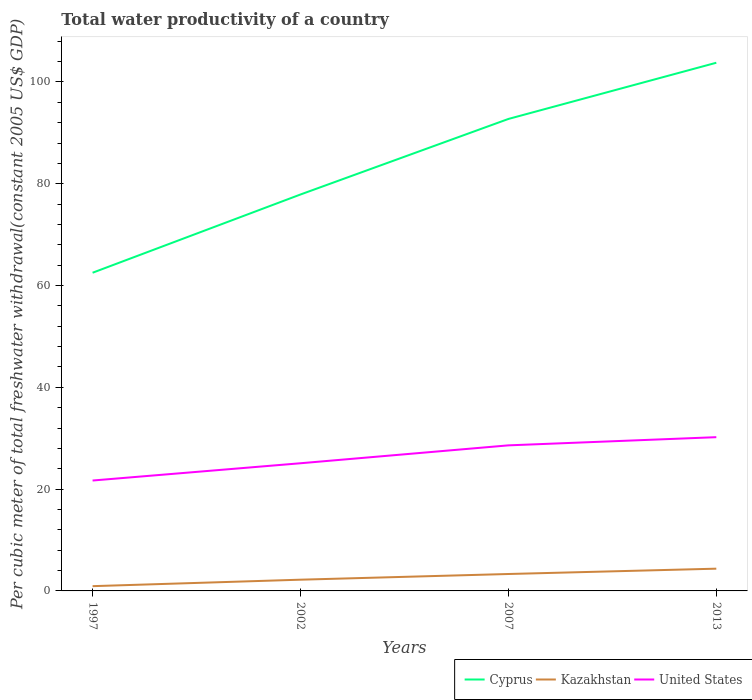Does the line corresponding to Cyprus intersect with the line corresponding to United States?
Your answer should be very brief. No. Is the number of lines equal to the number of legend labels?
Ensure brevity in your answer.  Yes. Across all years, what is the maximum total water productivity in Kazakhstan?
Provide a succinct answer. 0.94. What is the total total water productivity in Cyprus in the graph?
Your answer should be very brief. -14.84. What is the difference between the highest and the second highest total water productivity in Kazakhstan?
Your response must be concise. 3.44. Is the total water productivity in Cyprus strictly greater than the total water productivity in United States over the years?
Offer a very short reply. No. How many lines are there?
Make the answer very short. 3. How many years are there in the graph?
Your answer should be very brief. 4. What is the difference between two consecutive major ticks on the Y-axis?
Keep it short and to the point. 20. Are the values on the major ticks of Y-axis written in scientific E-notation?
Keep it short and to the point. No. Does the graph contain grids?
Keep it short and to the point. No. How many legend labels are there?
Ensure brevity in your answer.  3. How are the legend labels stacked?
Your answer should be very brief. Horizontal. What is the title of the graph?
Keep it short and to the point. Total water productivity of a country. What is the label or title of the Y-axis?
Ensure brevity in your answer.  Per cubic meter of total freshwater withdrawal(constant 2005 US$ GDP). What is the Per cubic meter of total freshwater withdrawal(constant 2005 US$ GDP) of Cyprus in 1997?
Your answer should be very brief. 62.52. What is the Per cubic meter of total freshwater withdrawal(constant 2005 US$ GDP) of Kazakhstan in 1997?
Your answer should be very brief. 0.94. What is the Per cubic meter of total freshwater withdrawal(constant 2005 US$ GDP) in United States in 1997?
Keep it short and to the point. 21.69. What is the Per cubic meter of total freshwater withdrawal(constant 2005 US$ GDP) of Cyprus in 2002?
Offer a terse response. 77.89. What is the Per cubic meter of total freshwater withdrawal(constant 2005 US$ GDP) of Kazakhstan in 2002?
Offer a very short reply. 2.21. What is the Per cubic meter of total freshwater withdrawal(constant 2005 US$ GDP) in United States in 2002?
Your answer should be very brief. 25.08. What is the Per cubic meter of total freshwater withdrawal(constant 2005 US$ GDP) in Cyprus in 2007?
Ensure brevity in your answer.  92.73. What is the Per cubic meter of total freshwater withdrawal(constant 2005 US$ GDP) in Kazakhstan in 2007?
Your answer should be compact. 3.32. What is the Per cubic meter of total freshwater withdrawal(constant 2005 US$ GDP) of United States in 2007?
Offer a terse response. 28.6. What is the Per cubic meter of total freshwater withdrawal(constant 2005 US$ GDP) of Cyprus in 2013?
Your answer should be compact. 103.77. What is the Per cubic meter of total freshwater withdrawal(constant 2005 US$ GDP) in Kazakhstan in 2013?
Make the answer very short. 4.37. What is the Per cubic meter of total freshwater withdrawal(constant 2005 US$ GDP) in United States in 2013?
Your answer should be compact. 30.21. Across all years, what is the maximum Per cubic meter of total freshwater withdrawal(constant 2005 US$ GDP) of Cyprus?
Your answer should be compact. 103.77. Across all years, what is the maximum Per cubic meter of total freshwater withdrawal(constant 2005 US$ GDP) in Kazakhstan?
Your answer should be compact. 4.37. Across all years, what is the maximum Per cubic meter of total freshwater withdrawal(constant 2005 US$ GDP) in United States?
Keep it short and to the point. 30.21. Across all years, what is the minimum Per cubic meter of total freshwater withdrawal(constant 2005 US$ GDP) of Cyprus?
Your answer should be very brief. 62.52. Across all years, what is the minimum Per cubic meter of total freshwater withdrawal(constant 2005 US$ GDP) in Kazakhstan?
Keep it short and to the point. 0.94. Across all years, what is the minimum Per cubic meter of total freshwater withdrawal(constant 2005 US$ GDP) in United States?
Your response must be concise. 21.69. What is the total Per cubic meter of total freshwater withdrawal(constant 2005 US$ GDP) in Cyprus in the graph?
Provide a succinct answer. 336.9. What is the total Per cubic meter of total freshwater withdrawal(constant 2005 US$ GDP) in Kazakhstan in the graph?
Ensure brevity in your answer.  10.84. What is the total Per cubic meter of total freshwater withdrawal(constant 2005 US$ GDP) of United States in the graph?
Provide a succinct answer. 105.58. What is the difference between the Per cubic meter of total freshwater withdrawal(constant 2005 US$ GDP) in Cyprus in 1997 and that in 2002?
Provide a succinct answer. -15.37. What is the difference between the Per cubic meter of total freshwater withdrawal(constant 2005 US$ GDP) of Kazakhstan in 1997 and that in 2002?
Your answer should be very brief. -1.27. What is the difference between the Per cubic meter of total freshwater withdrawal(constant 2005 US$ GDP) in United States in 1997 and that in 2002?
Your response must be concise. -3.39. What is the difference between the Per cubic meter of total freshwater withdrawal(constant 2005 US$ GDP) of Cyprus in 1997 and that in 2007?
Offer a terse response. -30.21. What is the difference between the Per cubic meter of total freshwater withdrawal(constant 2005 US$ GDP) of Kazakhstan in 1997 and that in 2007?
Give a very brief answer. -2.39. What is the difference between the Per cubic meter of total freshwater withdrawal(constant 2005 US$ GDP) in United States in 1997 and that in 2007?
Your response must be concise. -6.91. What is the difference between the Per cubic meter of total freshwater withdrawal(constant 2005 US$ GDP) in Cyprus in 1997 and that in 2013?
Provide a short and direct response. -41.26. What is the difference between the Per cubic meter of total freshwater withdrawal(constant 2005 US$ GDP) of Kazakhstan in 1997 and that in 2013?
Keep it short and to the point. -3.44. What is the difference between the Per cubic meter of total freshwater withdrawal(constant 2005 US$ GDP) in United States in 1997 and that in 2013?
Provide a succinct answer. -8.52. What is the difference between the Per cubic meter of total freshwater withdrawal(constant 2005 US$ GDP) of Cyprus in 2002 and that in 2007?
Your answer should be compact. -14.84. What is the difference between the Per cubic meter of total freshwater withdrawal(constant 2005 US$ GDP) in Kazakhstan in 2002 and that in 2007?
Keep it short and to the point. -1.12. What is the difference between the Per cubic meter of total freshwater withdrawal(constant 2005 US$ GDP) of United States in 2002 and that in 2007?
Offer a terse response. -3.52. What is the difference between the Per cubic meter of total freshwater withdrawal(constant 2005 US$ GDP) in Cyprus in 2002 and that in 2013?
Give a very brief answer. -25.88. What is the difference between the Per cubic meter of total freshwater withdrawal(constant 2005 US$ GDP) in Kazakhstan in 2002 and that in 2013?
Your response must be concise. -2.17. What is the difference between the Per cubic meter of total freshwater withdrawal(constant 2005 US$ GDP) in United States in 2002 and that in 2013?
Provide a short and direct response. -5.12. What is the difference between the Per cubic meter of total freshwater withdrawal(constant 2005 US$ GDP) of Cyprus in 2007 and that in 2013?
Provide a succinct answer. -11.04. What is the difference between the Per cubic meter of total freshwater withdrawal(constant 2005 US$ GDP) in Kazakhstan in 2007 and that in 2013?
Your answer should be compact. -1.05. What is the difference between the Per cubic meter of total freshwater withdrawal(constant 2005 US$ GDP) in United States in 2007 and that in 2013?
Your answer should be compact. -1.61. What is the difference between the Per cubic meter of total freshwater withdrawal(constant 2005 US$ GDP) of Cyprus in 1997 and the Per cubic meter of total freshwater withdrawal(constant 2005 US$ GDP) of Kazakhstan in 2002?
Your response must be concise. 60.31. What is the difference between the Per cubic meter of total freshwater withdrawal(constant 2005 US$ GDP) of Cyprus in 1997 and the Per cubic meter of total freshwater withdrawal(constant 2005 US$ GDP) of United States in 2002?
Keep it short and to the point. 37.43. What is the difference between the Per cubic meter of total freshwater withdrawal(constant 2005 US$ GDP) of Kazakhstan in 1997 and the Per cubic meter of total freshwater withdrawal(constant 2005 US$ GDP) of United States in 2002?
Your response must be concise. -24.15. What is the difference between the Per cubic meter of total freshwater withdrawal(constant 2005 US$ GDP) in Cyprus in 1997 and the Per cubic meter of total freshwater withdrawal(constant 2005 US$ GDP) in Kazakhstan in 2007?
Your answer should be very brief. 59.19. What is the difference between the Per cubic meter of total freshwater withdrawal(constant 2005 US$ GDP) of Cyprus in 1997 and the Per cubic meter of total freshwater withdrawal(constant 2005 US$ GDP) of United States in 2007?
Give a very brief answer. 33.92. What is the difference between the Per cubic meter of total freshwater withdrawal(constant 2005 US$ GDP) of Kazakhstan in 1997 and the Per cubic meter of total freshwater withdrawal(constant 2005 US$ GDP) of United States in 2007?
Your response must be concise. -27.66. What is the difference between the Per cubic meter of total freshwater withdrawal(constant 2005 US$ GDP) in Cyprus in 1997 and the Per cubic meter of total freshwater withdrawal(constant 2005 US$ GDP) in Kazakhstan in 2013?
Your answer should be very brief. 58.14. What is the difference between the Per cubic meter of total freshwater withdrawal(constant 2005 US$ GDP) of Cyprus in 1997 and the Per cubic meter of total freshwater withdrawal(constant 2005 US$ GDP) of United States in 2013?
Provide a short and direct response. 32.31. What is the difference between the Per cubic meter of total freshwater withdrawal(constant 2005 US$ GDP) of Kazakhstan in 1997 and the Per cubic meter of total freshwater withdrawal(constant 2005 US$ GDP) of United States in 2013?
Your answer should be compact. -29.27. What is the difference between the Per cubic meter of total freshwater withdrawal(constant 2005 US$ GDP) of Cyprus in 2002 and the Per cubic meter of total freshwater withdrawal(constant 2005 US$ GDP) of Kazakhstan in 2007?
Your response must be concise. 74.56. What is the difference between the Per cubic meter of total freshwater withdrawal(constant 2005 US$ GDP) in Cyprus in 2002 and the Per cubic meter of total freshwater withdrawal(constant 2005 US$ GDP) in United States in 2007?
Provide a short and direct response. 49.29. What is the difference between the Per cubic meter of total freshwater withdrawal(constant 2005 US$ GDP) in Kazakhstan in 2002 and the Per cubic meter of total freshwater withdrawal(constant 2005 US$ GDP) in United States in 2007?
Make the answer very short. -26.39. What is the difference between the Per cubic meter of total freshwater withdrawal(constant 2005 US$ GDP) of Cyprus in 2002 and the Per cubic meter of total freshwater withdrawal(constant 2005 US$ GDP) of Kazakhstan in 2013?
Make the answer very short. 73.52. What is the difference between the Per cubic meter of total freshwater withdrawal(constant 2005 US$ GDP) in Cyprus in 2002 and the Per cubic meter of total freshwater withdrawal(constant 2005 US$ GDP) in United States in 2013?
Make the answer very short. 47.68. What is the difference between the Per cubic meter of total freshwater withdrawal(constant 2005 US$ GDP) of Kazakhstan in 2002 and the Per cubic meter of total freshwater withdrawal(constant 2005 US$ GDP) of United States in 2013?
Your response must be concise. -28. What is the difference between the Per cubic meter of total freshwater withdrawal(constant 2005 US$ GDP) in Cyprus in 2007 and the Per cubic meter of total freshwater withdrawal(constant 2005 US$ GDP) in Kazakhstan in 2013?
Your response must be concise. 88.36. What is the difference between the Per cubic meter of total freshwater withdrawal(constant 2005 US$ GDP) of Cyprus in 2007 and the Per cubic meter of total freshwater withdrawal(constant 2005 US$ GDP) of United States in 2013?
Offer a terse response. 62.52. What is the difference between the Per cubic meter of total freshwater withdrawal(constant 2005 US$ GDP) in Kazakhstan in 2007 and the Per cubic meter of total freshwater withdrawal(constant 2005 US$ GDP) in United States in 2013?
Offer a terse response. -26.88. What is the average Per cubic meter of total freshwater withdrawal(constant 2005 US$ GDP) in Cyprus per year?
Your answer should be compact. 84.23. What is the average Per cubic meter of total freshwater withdrawal(constant 2005 US$ GDP) of Kazakhstan per year?
Your response must be concise. 2.71. What is the average Per cubic meter of total freshwater withdrawal(constant 2005 US$ GDP) in United States per year?
Ensure brevity in your answer.  26.4. In the year 1997, what is the difference between the Per cubic meter of total freshwater withdrawal(constant 2005 US$ GDP) in Cyprus and Per cubic meter of total freshwater withdrawal(constant 2005 US$ GDP) in Kazakhstan?
Ensure brevity in your answer.  61.58. In the year 1997, what is the difference between the Per cubic meter of total freshwater withdrawal(constant 2005 US$ GDP) of Cyprus and Per cubic meter of total freshwater withdrawal(constant 2005 US$ GDP) of United States?
Provide a succinct answer. 40.83. In the year 1997, what is the difference between the Per cubic meter of total freshwater withdrawal(constant 2005 US$ GDP) of Kazakhstan and Per cubic meter of total freshwater withdrawal(constant 2005 US$ GDP) of United States?
Give a very brief answer. -20.75. In the year 2002, what is the difference between the Per cubic meter of total freshwater withdrawal(constant 2005 US$ GDP) of Cyprus and Per cubic meter of total freshwater withdrawal(constant 2005 US$ GDP) of Kazakhstan?
Your answer should be compact. 75.68. In the year 2002, what is the difference between the Per cubic meter of total freshwater withdrawal(constant 2005 US$ GDP) of Cyprus and Per cubic meter of total freshwater withdrawal(constant 2005 US$ GDP) of United States?
Offer a very short reply. 52.8. In the year 2002, what is the difference between the Per cubic meter of total freshwater withdrawal(constant 2005 US$ GDP) in Kazakhstan and Per cubic meter of total freshwater withdrawal(constant 2005 US$ GDP) in United States?
Offer a very short reply. -22.88. In the year 2007, what is the difference between the Per cubic meter of total freshwater withdrawal(constant 2005 US$ GDP) of Cyprus and Per cubic meter of total freshwater withdrawal(constant 2005 US$ GDP) of Kazakhstan?
Offer a very short reply. 89.41. In the year 2007, what is the difference between the Per cubic meter of total freshwater withdrawal(constant 2005 US$ GDP) in Cyprus and Per cubic meter of total freshwater withdrawal(constant 2005 US$ GDP) in United States?
Make the answer very short. 64.13. In the year 2007, what is the difference between the Per cubic meter of total freshwater withdrawal(constant 2005 US$ GDP) of Kazakhstan and Per cubic meter of total freshwater withdrawal(constant 2005 US$ GDP) of United States?
Your response must be concise. -25.28. In the year 2013, what is the difference between the Per cubic meter of total freshwater withdrawal(constant 2005 US$ GDP) in Cyprus and Per cubic meter of total freshwater withdrawal(constant 2005 US$ GDP) in Kazakhstan?
Give a very brief answer. 99.4. In the year 2013, what is the difference between the Per cubic meter of total freshwater withdrawal(constant 2005 US$ GDP) in Cyprus and Per cubic meter of total freshwater withdrawal(constant 2005 US$ GDP) in United States?
Keep it short and to the point. 73.56. In the year 2013, what is the difference between the Per cubic meter of total freshwater withdrawal(constant 2005 US$ GDP) in Kazakhstan and Per cubic meter of total freshwater withdrawal(constant 2005 US$ GDP) in United States?
Offer a terse response. -25.84. What is the ratio of the Per cubic meter of total freshwater withdrawal(constant 2005 US$ GDP) in Cyprus in 1997 to that in 2002?
Ensure brevity in your answer.  0.8. What is the ratio of the Per cubic meter of total freshwater withdrawal(constant 2005 US$ GDP) of Kazakhstan in 1997 to that in 2002?
Make the answer very short. 0.42. What is the ratio of the Per cubic meter of total freshwater withdrawal(constant 2005 US$ GDP) of United States in 1997 to that in 2002?
Provide a short and direct response. 0.86. What is the ratio of the Per cubic meter of total freshwater withdrawal(constant 2005 US$ GDP) in Cyprus in 1997 to that in 2007?
Give a very brief answer. 0.67. What is the ratio of the Per cubic meter of total freshwater withdrawal(constant 2005 US$ GDP) in Kazakhstan in 1997 to that in 2007?
Keep it short and to the point. 0.28. What is the ratio of the Per cubic meter of total freshwater withdrawal(constant 2005 US$ GDP) in United States in 1997 to that in 2007?
Provide a succinct answer. 0.76. What is the ratio of the Per cubic meter of total freshwater withdrawal(constant 2005 US$ GDP) of Cyprus in 1997 to that in 2013?
Your answer should be very brief. 0.6. What is the ratio of the Per cubic meter of total freshwater withdrawal(constant 2005 US$ GDP) in Kazakhstan in 1997 to that in 2013?
Give a very brief answer. 0.21. What is the ratio of the Per cubic meter of total freshwater withdrawal(constant 2005 US$ GDP) in United States in 1997 to that in 2013?
Offer a terse response. 0.72. What is the ratio of the Per cubic meter of total freshwater withdrawal(constant 2005 US$ GDP) of Cyprus in 2002 to that in 2007?
Provide a short and direct response. 0.84. What is the ratio of the Per cubic meter of total freshwater withdrawal(constant 2005 US$ GDP) in Kazakhstan in 2002 to that in 2007?
Offer a very short reply. 0.66. What is the ratio of the Per cubic meter of total freshwater withdrawal(constant 2005 US$ GDP) in United States in 2002 to that in 2007?
Keep it short and to the point. 0.88. What is the ratio of the Per cubic meter of total freshwater withdrawal(constant 2005 US$ GDP) of Cyprus in 2002 to that in 2013?
Provide a short and direct response. 0.75. What is the ratio of the Per cubic meter of total freshwater withdrawal(constant 2005 US$ GDP) of Kazakhstan in 2002 to that in 2013?
Offer a very short reply. 0.5. What is the ratio of the Per cubic meter of total freshwater withdrawal(constant 2005 US$ GDP) in United States in 2002 to that in 2013?
Make the answer very short. 0.83. What is the ratio of the Per cubic meter of total freshwater withdrawal(constant 2005 US$ GDP) of Cyprus in 2007 to that in 2013?
Provide a succinct answer. 0.89. What is the ratio of the Per cubic meter of total freshwater withdrawal(constant 2005 US$ GDP) in Kazakhstan in 2007 to that in 2013?
Offer a terse response. 0.76. What is the ratio of the Per cubic meter of total freshwater withdrawal(constant 2005 US$ GDP) of United States in 2007 to that in 2013?
Your response must be concise. 0.95. What is the difference between the highest and the second highest Per cubic meter of total freshwater withdrawal(constant 2005 US$ GDP) in Cyprus?
Offer a very short reply. 11.04. What is the difference between the highest and the second highest Per cubic meter of total freshwater withdrawal(constant 2005 US$ GDP) in Kazakhstan?
Keep it short and to the point. 1.05. What is the difference between the highest and the second highest Per cubic meter of total freshwater withdrawal(constant 2005 US$ GDP) of United States?
Provide a succinct answer. 1.61. What is the difference between the highest and the lowest Per cubic meter of total freshwater withdrawal(constant 2005 US$ GDP) of Cyprus?
Make the answer very short. 41.26. What is the difference between the highest and the lowest Per cubic meter of total freshwater withdrawal(constant 2005 US$ GDP) of Kazakhstan?
Your response must be concise. 3.44. What is the difference between the highest and the lowest Per cubic meter of total freshwater withdrawal(constant 2005 US$ GDP) in United States?
Give a very brief answer. 8.52. 